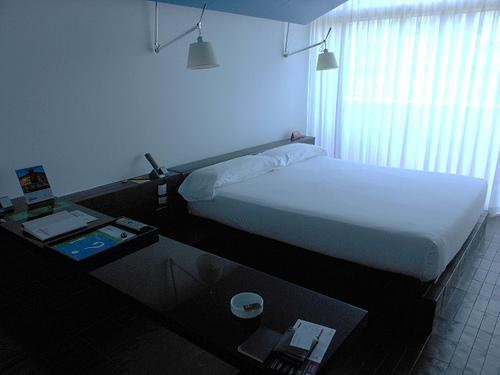Narrate the setting of a story that could take place in the room depicted in the image. In a peaceful sanctuary enveloped by sheer curtains, Ann felt serenity as she lay on a bed adorned with white sheets and pillows, surrounded by minimal furniture and subtle lighting. Provide a brief description of the most prominent objects in the image. A neatly made bed with white sheets, two white-pillowcased pillows, a black table with a calendar on it, and hanging lamps on a white wall are in the room. How would you describe the atmosphere of the room in the image? The room has a clean, minimalist atmosphere with predominantly black and white tones and a modern aesthetic. If the image were to be used as a background for a product advertisement, how would you describe its features? Our latest product perfectly complements the sleek and minimalist style of this immaculate room, featuring a crisp white bed, contemporary black table, and soothing ambient lighting. List five noticeable items displayed in the image. Bed with white sheets, two white pillows, black table, closed curtains, overhead lamps. In a sentence or two, describe the overall appearance of the space in the image. The image showcases a clean and organized room with a bed, table, and lamps, featuring a black-and-white color scheme. Mention the colors of the most prominent objects in the photo. The bedspread is white, the table is black, the wall is white, and the lamps and remote are also black. Imagine you're talking to a friend. Describe to them what you see in the image. So, there's this super tidy room with a bed that has white sheets and pillows, a black table, and lamps hanging on a white wall. Provide a poetic description of the image. A pristine haven, where monochrome dreams fill the air, lies a room with a bed of snowy sheets, and whispers of light from midnight-black lamps. Imagine describing the image in a listing for a hotel room. What are the main features of the room? Clean and sophisticated, our cozy rooms feature a comfortable bed with crisp white linens, a sleek black table, and elegant hanging lamps that accent the immaculate white walls. 